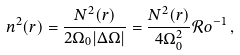Convert formula to latex. <formula><loc_0><loc_0><loc_500><loc_500>n ^ { 2 } ( r ) = \frac { N ^ { 2 } ( r ) } { 2 \Omega _ { 0 } | \Delta \Omega | } = \frac { N ^ { 2 } ( r ) } { 4 \Omega _ { 0 } ^ { 2 } } \mathcal { R } o ^ { - 1 } \, ,</formula> 